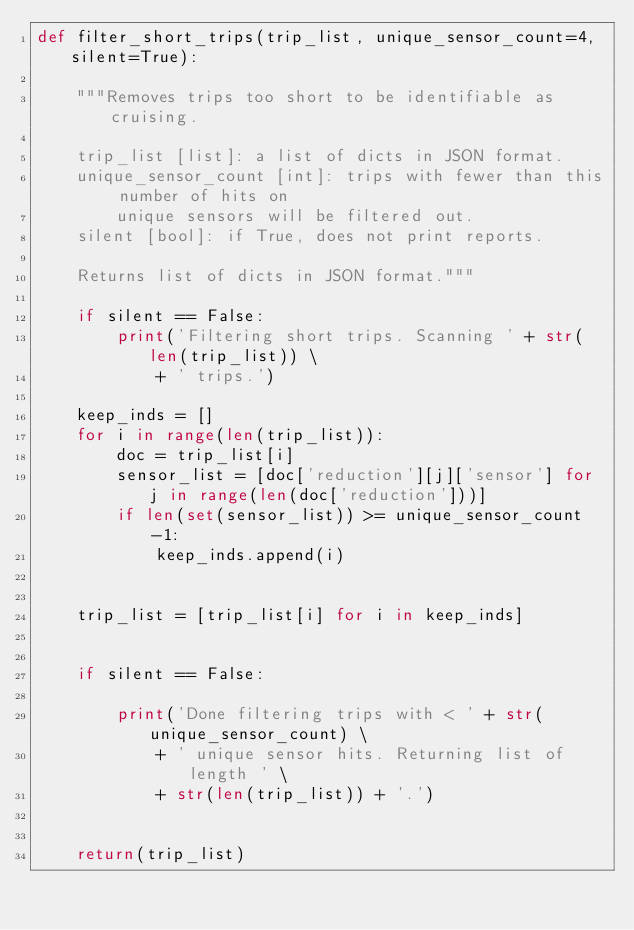Convert code to text. <code><loc_0><loc_0><loc_500><loc_500><_Python_>def filter_short_trips(trip_list, unique_sensor_count=4, silent=True):

    """Removes trips too short to be identifiable as cruising.

    trip_list [list]: a list of dicts in JSON format.
    unique_sensor_count [int]: trips with fewer than this number of hits on
        unique sensors will be filtered out.
    silent [bool]: if True, does not print reports.

    Returns list of dicts in JSON format."""

    if silent == False:
        print('Filtering short trips. Scanning ' + str(len(trip_list)) \
            + ' trips.')

    keep_inds = []
    for i in range(len(trip_list)):
        doc = trip_list[i]
        sensor_list = [doc['reduction'][j]['sensor'] for j in range(len(doc['reduction']))]
        if len(set(sensor_list)) >= unique_sensor_count-1:
            keep_inds.append(i)


    trip_list = [trip_list[i] for i in keep_inds]


    if silent == False:

        print('Done filtering trips with < ' + str(unique_sensor_count) \
            + ' unique sensor hits. Returning list of length ' \
            + str(len(trip_list)) + '.')


    return(trip_list)
</code> 